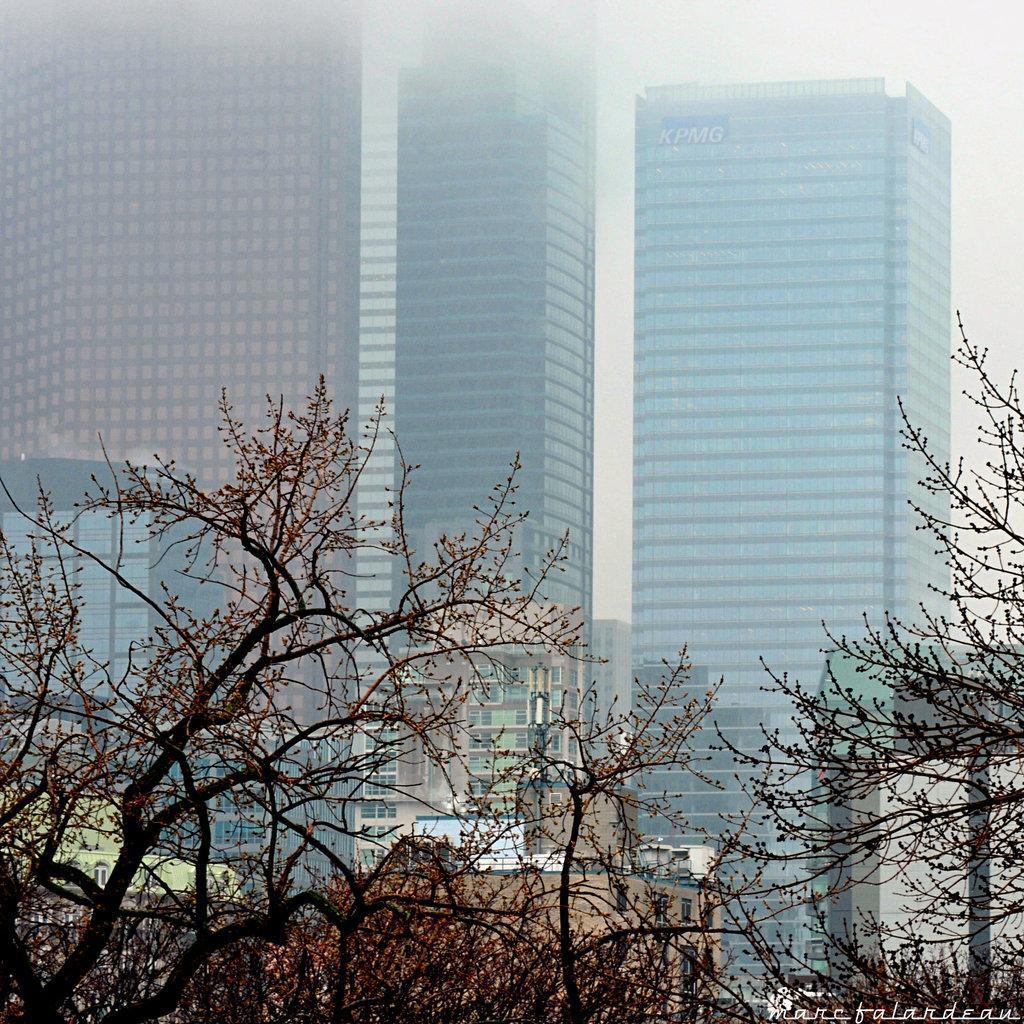Please provide a concise description of this image. In the image I can see the trees. In the background, I can see the tower buildings. 